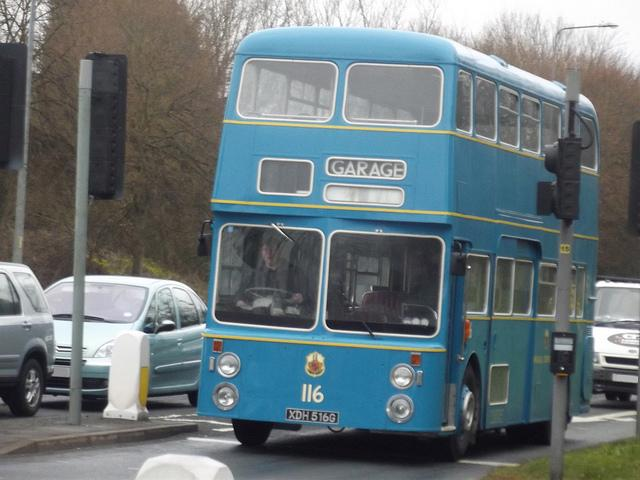Why is the bus without passengers? Please explain your reasoning. garage bound. The bus has a sign that says it is headed to the garage. 